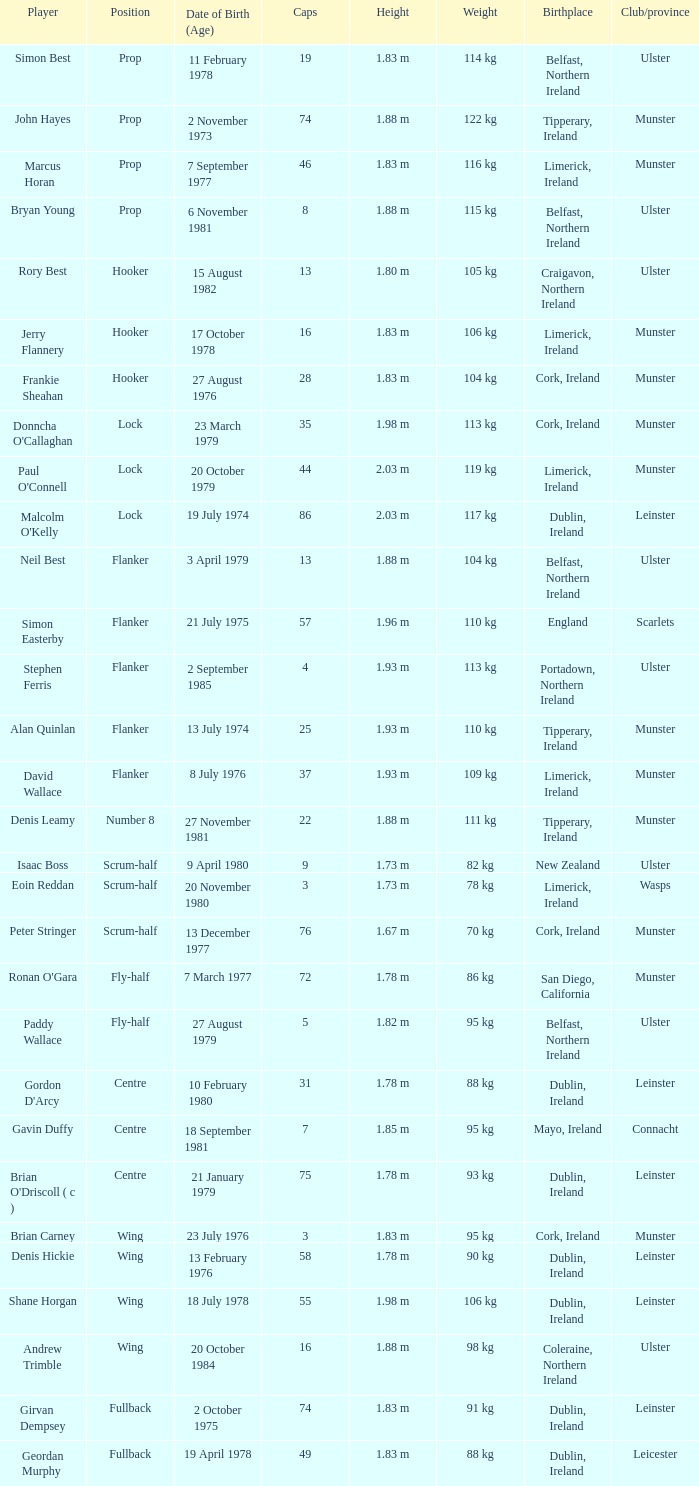Which Ulster player has fewer than 49 caps and plays the wing position? Andrew Trimble. 